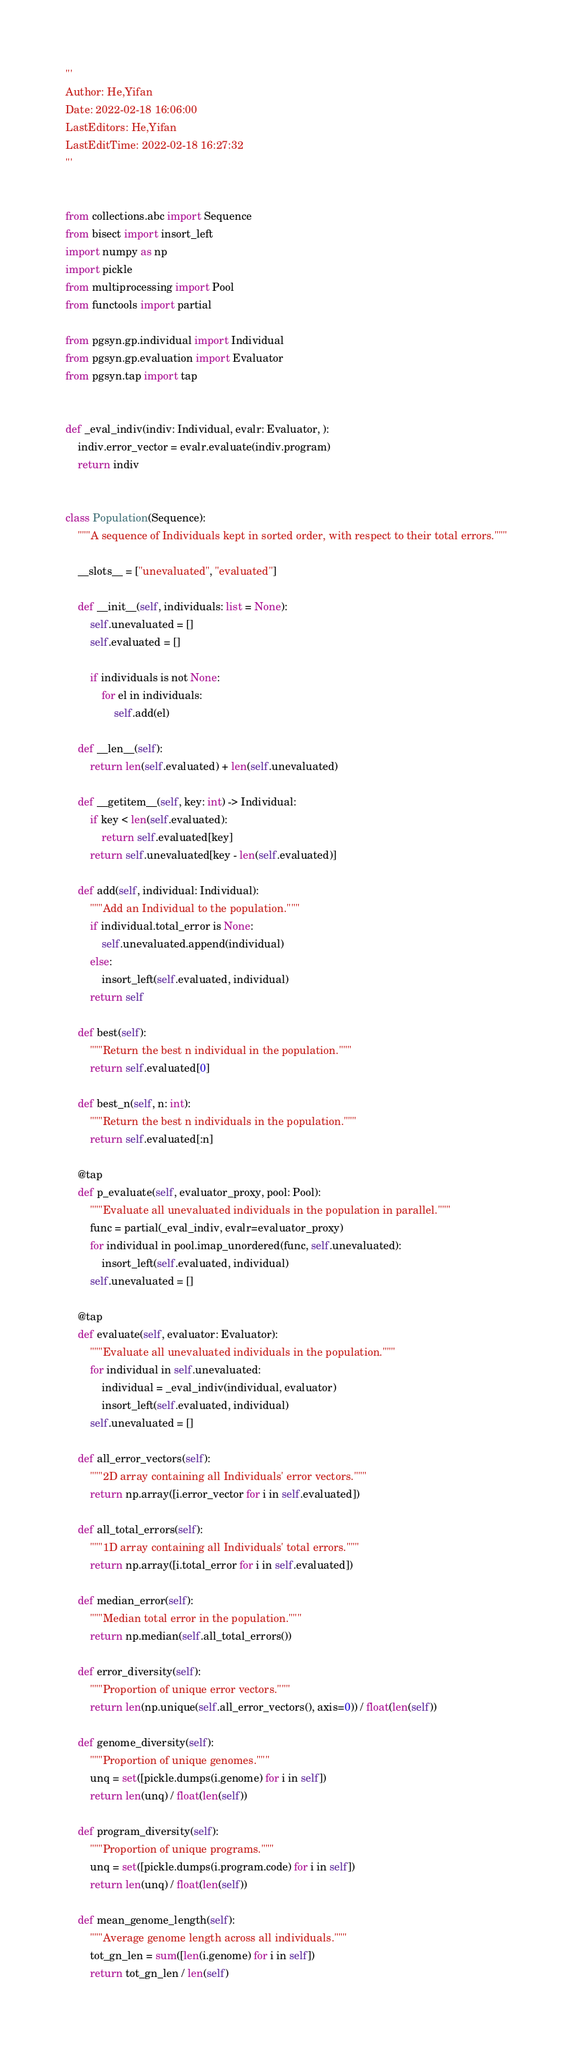Convert code to text. <code><loc_0><loc_0><loc_500><loc_500><_Python_>'''
Author: He,Yifan
Date: 2022-02-18 16:06:00
LastEditors: He,Yifan
LastEditTime: 2022-02-18 16:27:32
'''


from collections.abc import Sequence
from bisect import insort_left
import numpy as np
import pickle
from multiprocessing import Pool
from functools import partial

from pgsyn.gp.individual import Individual
from pgsyn.gp.evaluation import Evaluator
from pgsyn.tap import tap


def _eval_indiv(indiv: Individual, evalr: Evaluator, ):
    indiv.error_vector = evalr.evaluate(indiv.program)
    return indiv


class Population(Sequence):
    """A sequence of Individuals kept in sorted order, with respect to their total errors."""

    __slots__ = ["unevaluated", "evaluated"]

    def __init__(self, individuals: list = None):
        self.unevaluated = []
        self.evaluated = []

        if individuals is not None:
            for el in individuals:
                self.add(el)

    def __len__(self):
        return len(self.evaluated) + len(self.unevaluated)

    def __getitem__(self, key: int) -> Individual:
        if key < len(self.evaluated):
            return self.evaluated[key]
        return self.unevaluated[key - len(self.evaluated)]

    def add(self, individual: Individual):
        """Add an Individual to the population."""
        if individual.total_error is None:
            self.unevaluated.append(individual)
        else:
            insort_left(self.evaluated, individual)
        return self

    def best(self):
        """Return the best n individual in the population."""
        return self.evaluated[0]

    def best_n(self, n: int):
        """Return the best n individuals in the population."""
        return self.evaluated[:n]

    @tap
    def p_evaluate(self, evaluator_proxy, pool: Pool):
        """Evaluate all unevaluated individuals in the population in parallel."""
        func = partial(_eval_indiv, evalr=evaluator_proxy)
        for individual in pool.imap_unordered(func, self.unevaluated):
            insort_left(self.evaluated, individual)
        self.unevaluated = []

    @tap
    def evaluate(self, evaluator: Evaluator):
        """Evaluate all unevaluated individuals in the population."""
        for individual in self.unevaluated:
            individual = _eval_indiv(individual, evaluator)
            insort_left(self.evaluated, individual)
        self.unevaluated = []

    def all_error_vectors(self):
        """2D array containing all Individuals' error vectors."""
        return np.array([i.error_vector for i in self.evaluated])

    def all_total_errors(self):
        """1D array containing all Individuals' total errors."""
        return np.array([i.total_error for i in self.evaluated])

    def median_error(self):
        """Median total error in the population."""
        return np.median(self.all_total_errors())

    def error_diversity(self):
        """Proportion of unique error vectors."""
        return len(np.unique(self.all_error_vectors(), axis=0)) / float(len(self))

    def genome_diversity(self):
        """Proportion of unique genomes."""
        unq = set([pickle.dumps(i.genome) for i in self])
        return len(unq) / float(len(self))

    def program_diversity(self):
        """Proportion of unique programs."""
        unq = set([pickle.dumps(i.program.code) for i in self])
        return len(unq) / float(len(self))

    def mean_genome_length(self):
        """Average genome length across all individuals."""
        tot_gn_len = sum([len(i.genome) for i in self])
        return tot_gn_len / len(self)
</code> 